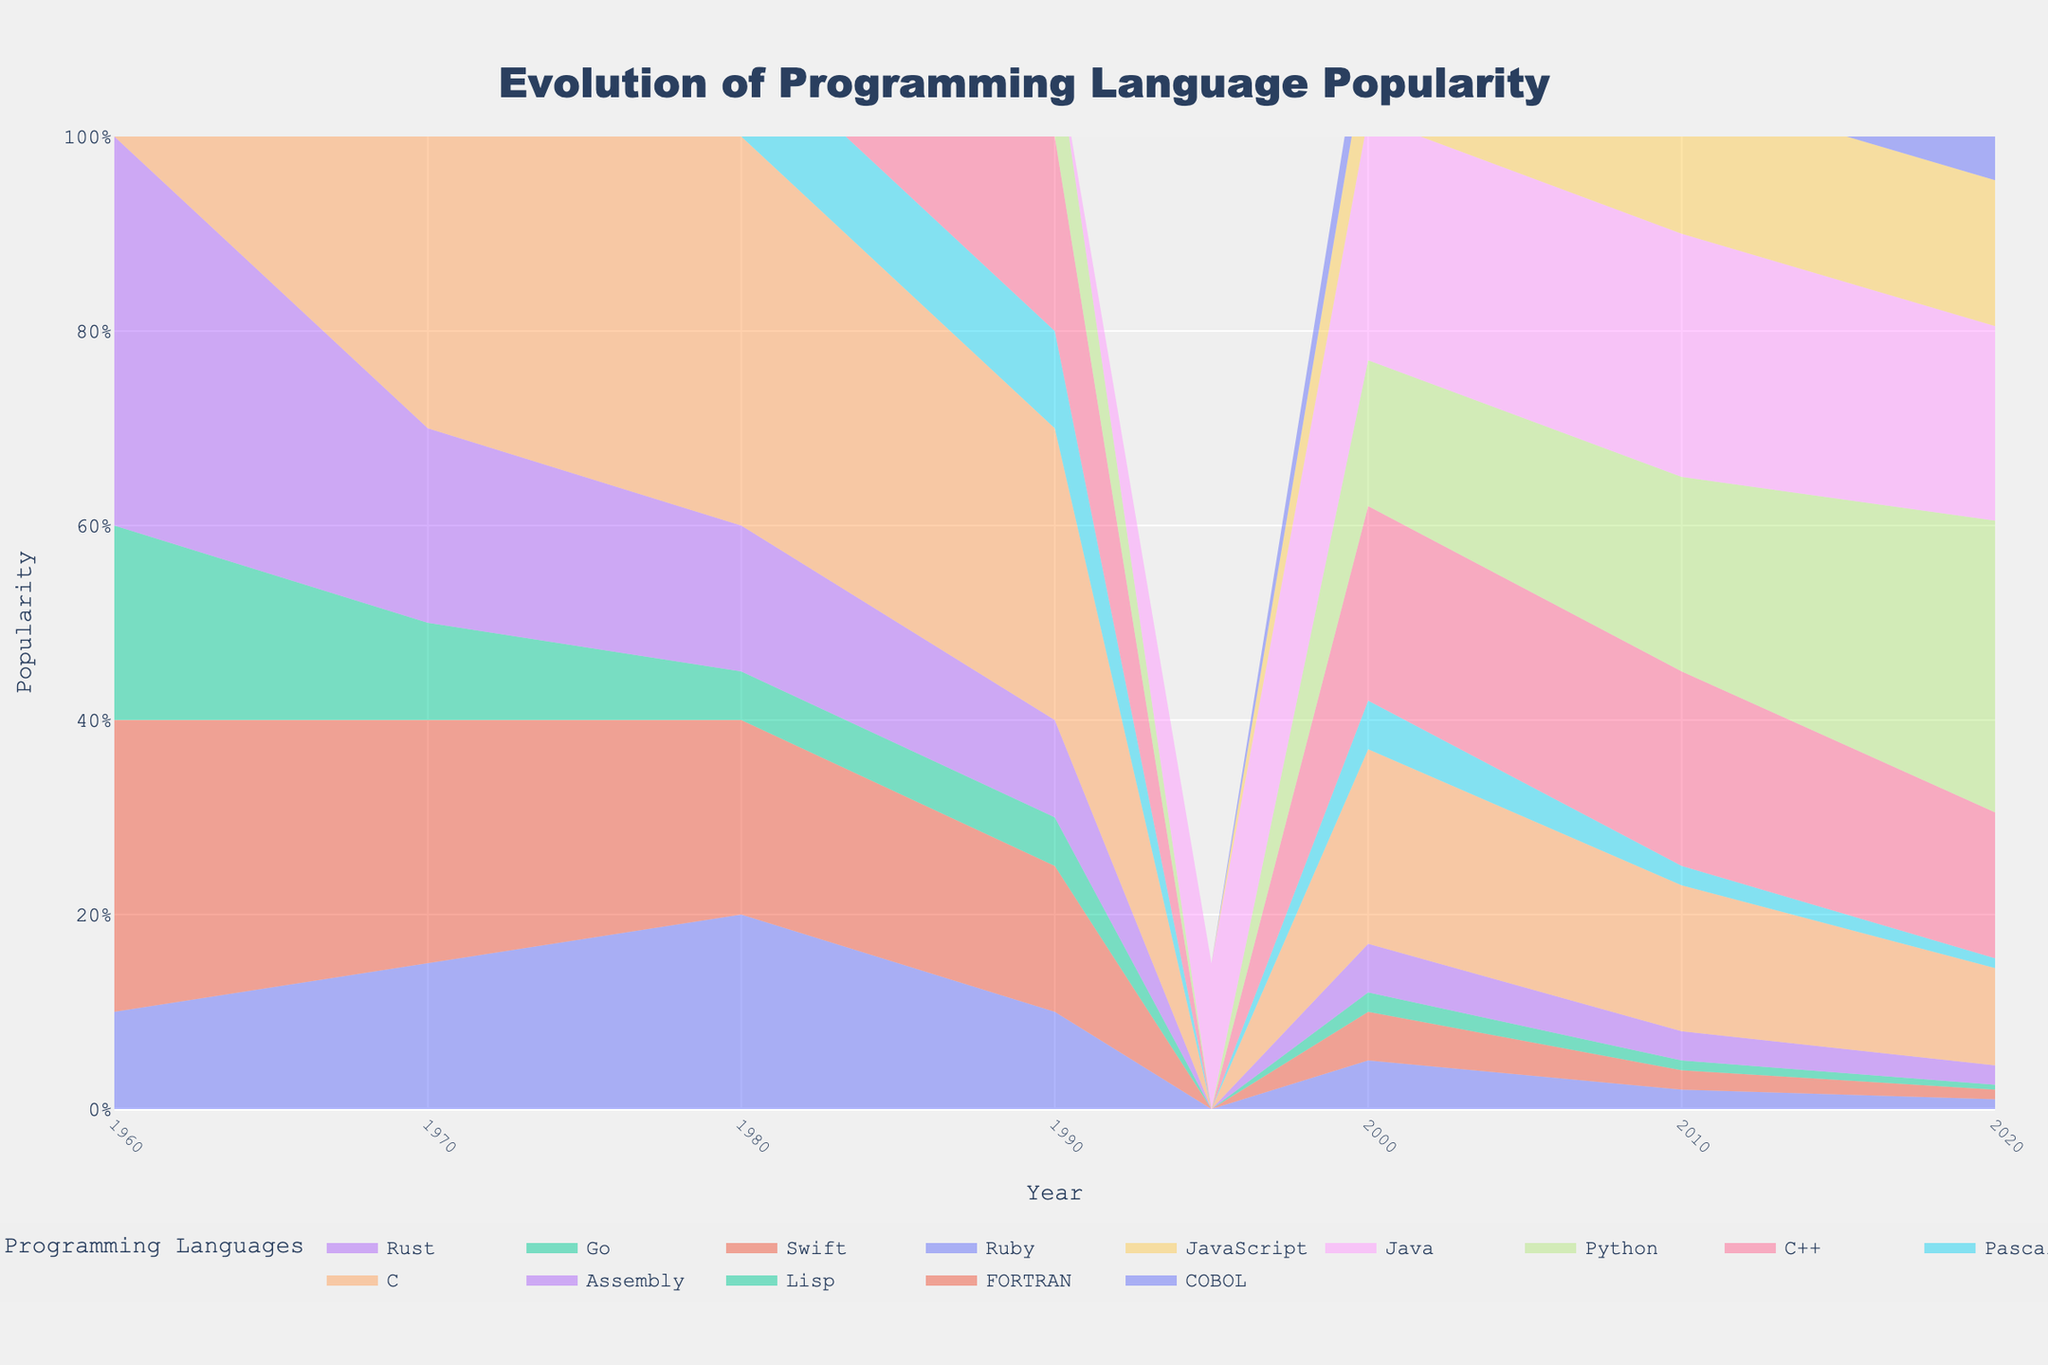what's the title of the figure? The title is displayed prominently at the top of the figure. It reads 'Evolution of Programming Language Popularity.'
Answer: Evolution of Programming Language Popularity what are the x-axis and y-axis labels on the chart? The x-axis is labeled 'Year,' indicating the time periods from 1960 to 2020, while the y-axis is labeled 'Popularity,' representing the popularity of different programming languages over time.
Answer: Year, Popularity which programming language showed the largest increase in popularity between 2000 and 2020? Looking at the step area chart, Python shows a substantial increase in the area towards the top, indicating it had the largest increase in popularity from 0.15 in 2000 to 0.3 in 2020.
Answer: Python how did the popularity of COBOL change between 1960 and 2020? The extension of COBOL's color band diminishes from 1960 (0.1) to 2020 (0.01), indicating a steady decline in its popularity.
Answer: Declined compare the popularity of Lisp in 1970 and 1980. Referring to the heights of Lisp’s area in the step chart, it dropped from 0.1 in 1970 to 0.05 in 1980.
Answer: Decreased which programming languages show a noticeable rise in popularity in the 1990s? The area associated with Java appears for the first time in 1995 and Python also shows an increase, both indicating a noticeable rise in their popularity in the 1990s.
Answer: Java and Python in the year 2020, which programming language had the second highest popularity? By examining the heights of the color bands in 2020, Java holds the second highest popularity in that year, right after Python.
Answer: Java what is the combined popularity of C and C++ in the year 2000? From the chart, C had a popularity of 0.2 and C++ also had 0.2 in 2000. Adding these gives a total of 0.4.
Answer: 0.4 which programming language saw its popularity peak in the 1980s and then decline by 2020? Based on the chart, Pascal shows a peak at 0.1 in 1980 and a significant decline to near 0 by 2020.
Answer: Pascal describe the trend of Assembly language popularity from 1960 to 2020. The area for Assembly shows an initial high of 0.4 in 1960, subsequent drops through the decades, and a smaller area of 0.02 by 2020, indicating a clear decline.
Answer: Decline 